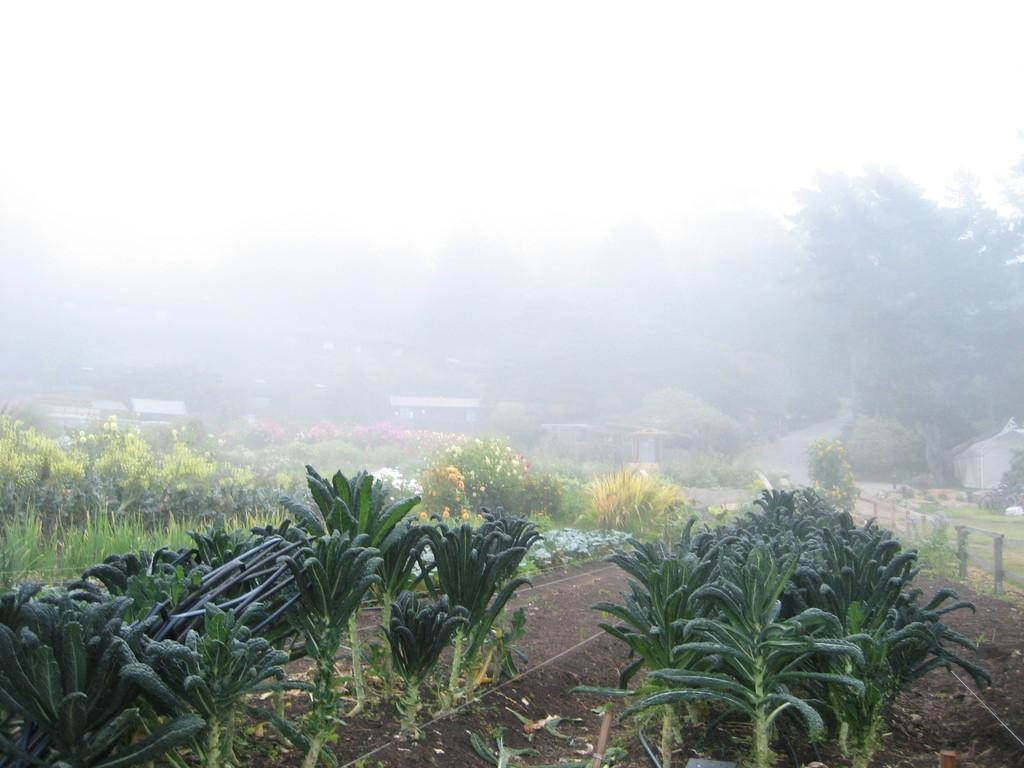What type of area is depicted in the image? There is a small field in the image. What can be found in the field? The field contains green plants. What can be seen in the background of the image? There are colorful flower plants and trees visible in the background. What atmospheric condition is present in the background? Fog is present in the background. What type of brass instrument is being played by the mom in the image? There is no brass instrument or mom present in the image; it features a small field with green plants and a background with colorful flower plants, trees, and fog. 